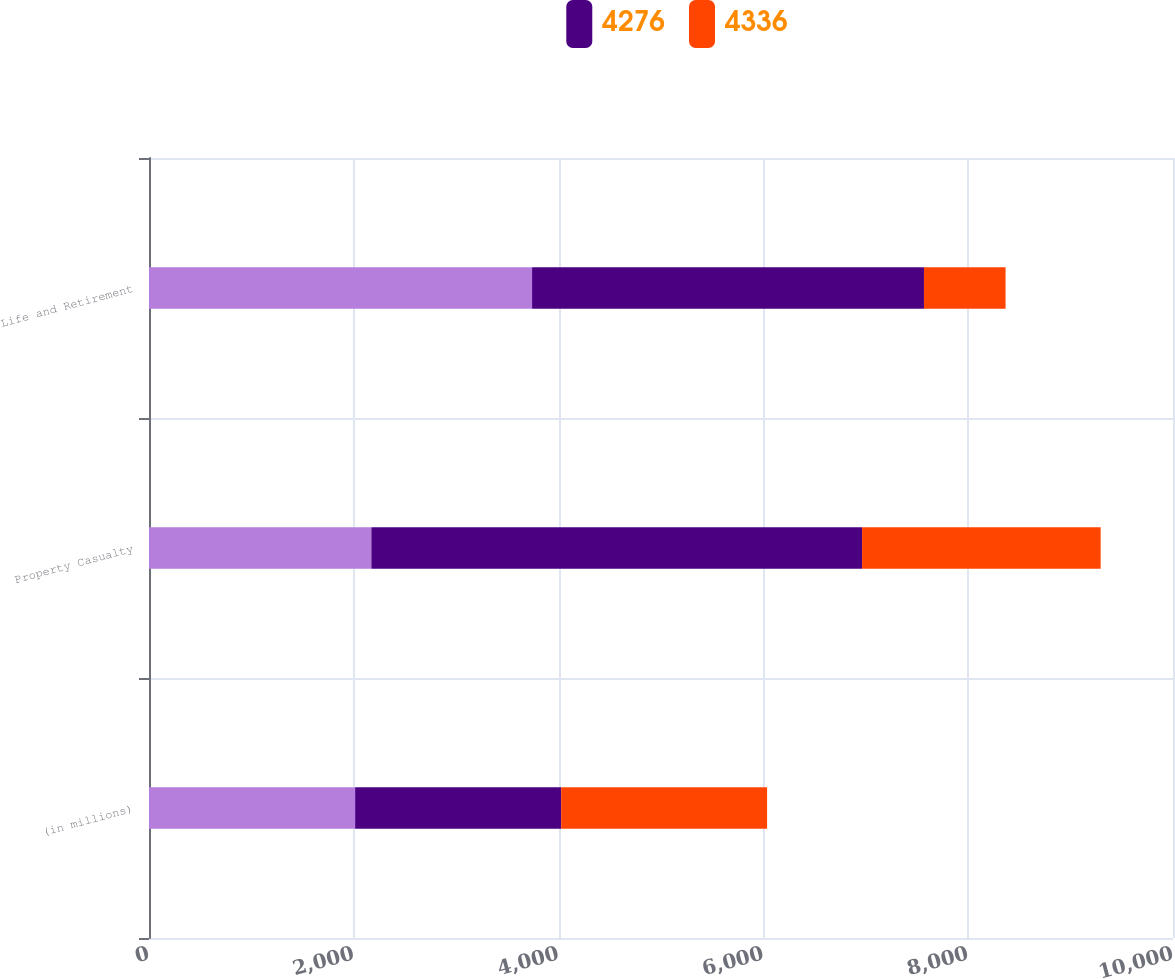Convert chart to OTSL. <chart><loc_0><loc_0><loc_500><loc_500><stacked_bar_chart><ecel><fcel>(in millions)<fcel>Property Casualty<fcel>Life and Retirement<nl><fcel>nan<fcel>2013<fcel>2171.5<fcel>3741<nl><fcel>4276<fcel>2012<fcel>4792<fcel>3827<nl><fcel>4336<fcel>2011<fcel>2330<fcel>797<nl></chart> 